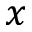Convert formula to latex. <formula><loc_0><loc_0><loc_500><loc_500>x</formula> 